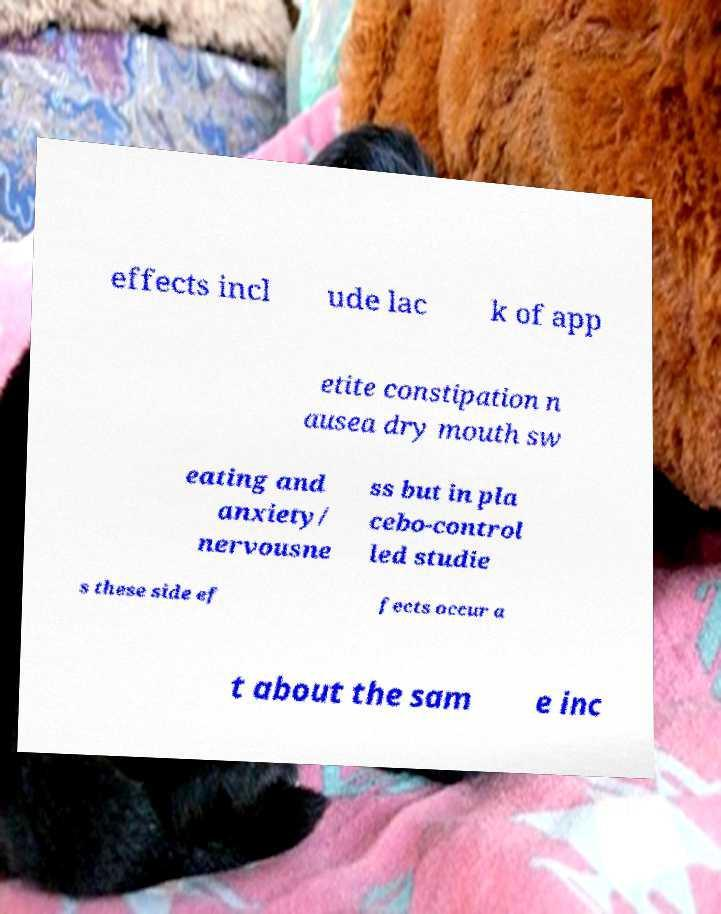Can you read and provide the text displayed in the image?This photo seems to have some interesting text. Can you extract and type it out for me? effects incl ude lac k of app etite constipation n ausea dry mouth sw eating and anxiety/ nervousne ss but in pla cebo-control led studie s these side ef fects occur a t about the sam e inc 